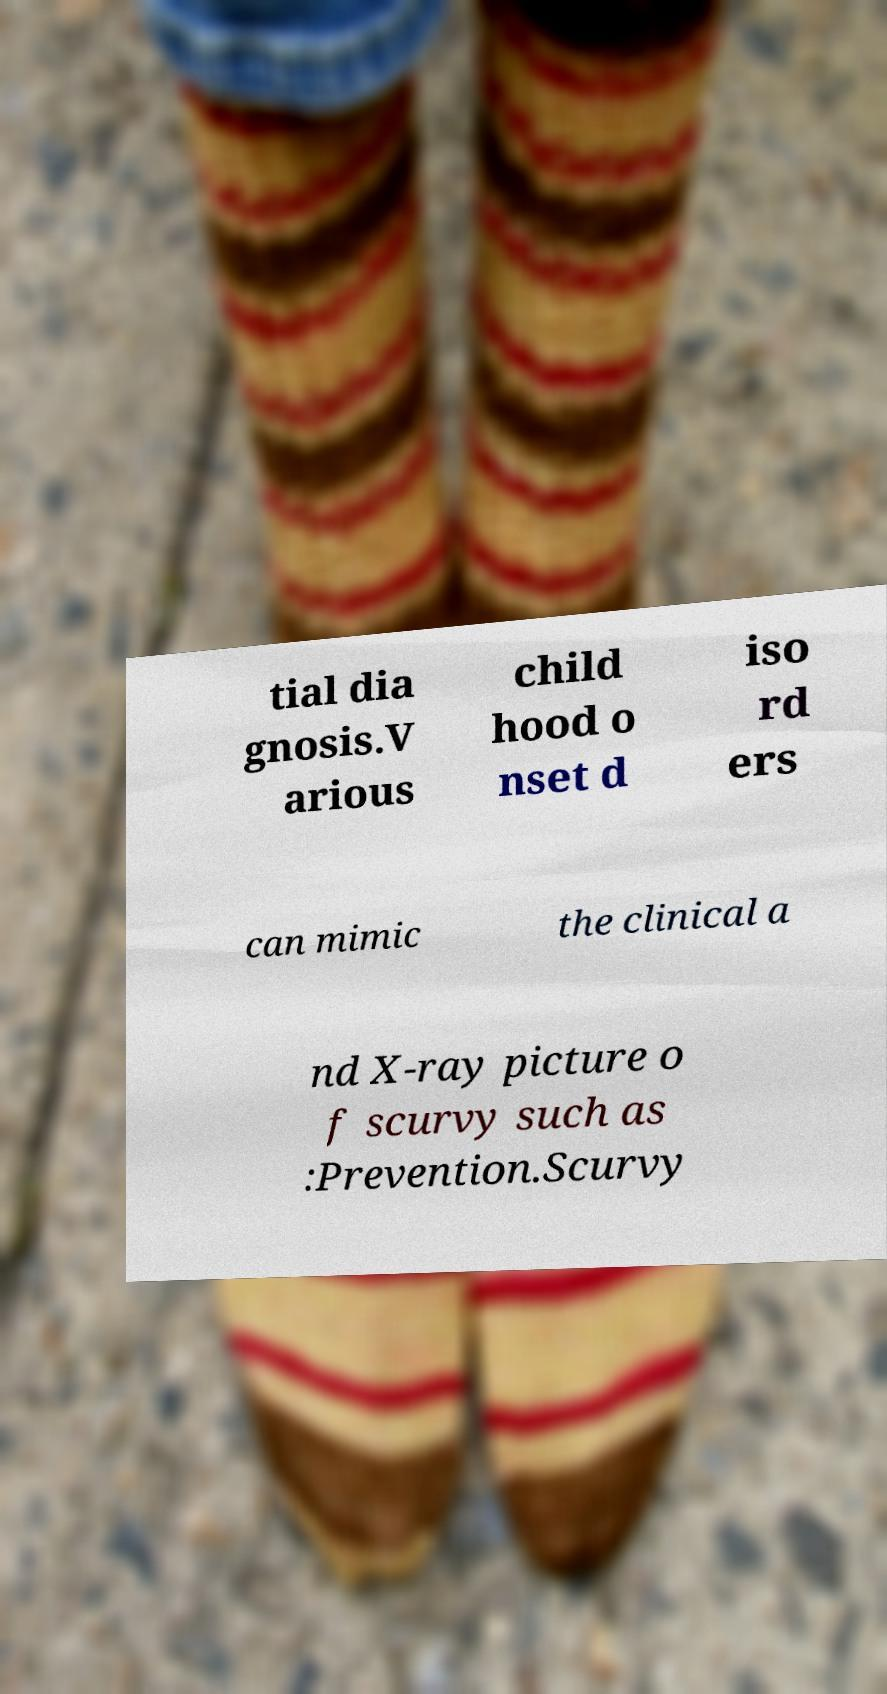Please read and relay the text visible in this image. What does it say? tial dia gnosis.V arious child hood o nset d iso rd ers can mimic the clinical a nd X-ray picture o f scurvy such as :Prevention.Scurvy 